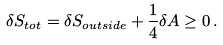Convert formula to latex. <formula><loc_0><loc_0><loc_500><loc_500>\delta S _ { t o t } = \delta S _ { o u t s i d e } + \frac { 1 } { 4 } \delta A \geq 0 \, .</formula> 